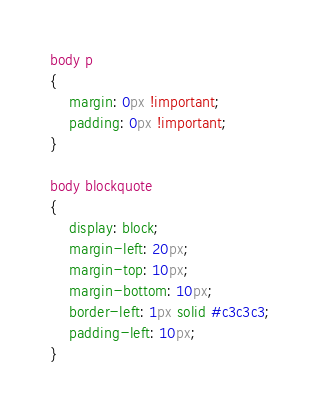<code> <loc_0><loc_0><loc_500><loc_500><_CSS_>body p
{
	margin: 0px !important;
	padding: 0px !important;
}

body blockquote
{
	display: block;
	margin-left: 20px;
	margin-top: 10px;
	margin-bottom: 10px;
	border-left: 1px solid #c3c3c3;
	padding-left: 10px;
}

</code> 